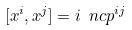Convert formula to latex. <formula><loc_0><loc_0><loc_500><loc_500>[ x ^ { i } , x ^ { j } ] = i \ n c p ^ { i j }</formula> 